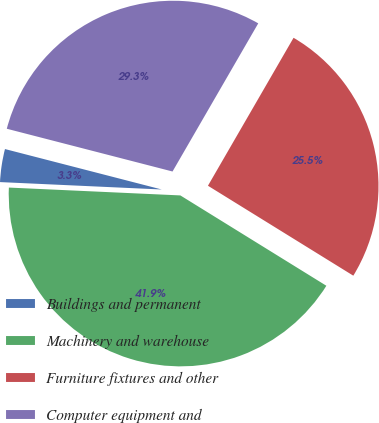Convert chart to OTSL. <chart><loc_0><loc_0><loc_500><loc_500><pie_chart><fcel>Buildings and permanent<fcel>Machinery and warehouse<fcel>Furniture fixtures and other<fcel>Computer equipment and<nl><fcel>3.29%<fcel>41.91%<fcel>25.47%<fcel>29.33%<nl></chart> 